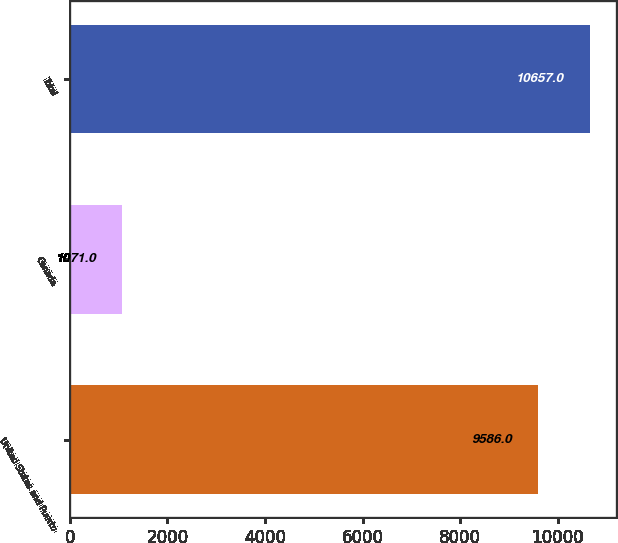Convert chart to OTSL. <chart><loc_0><loc_0><loc_500><loc_500><bar_chart><fcel>United States and Puerto<fcel>Canada<fcel>Total<nl><fcel>9586<fcel>1071<fcel>10657<nl></chart> 